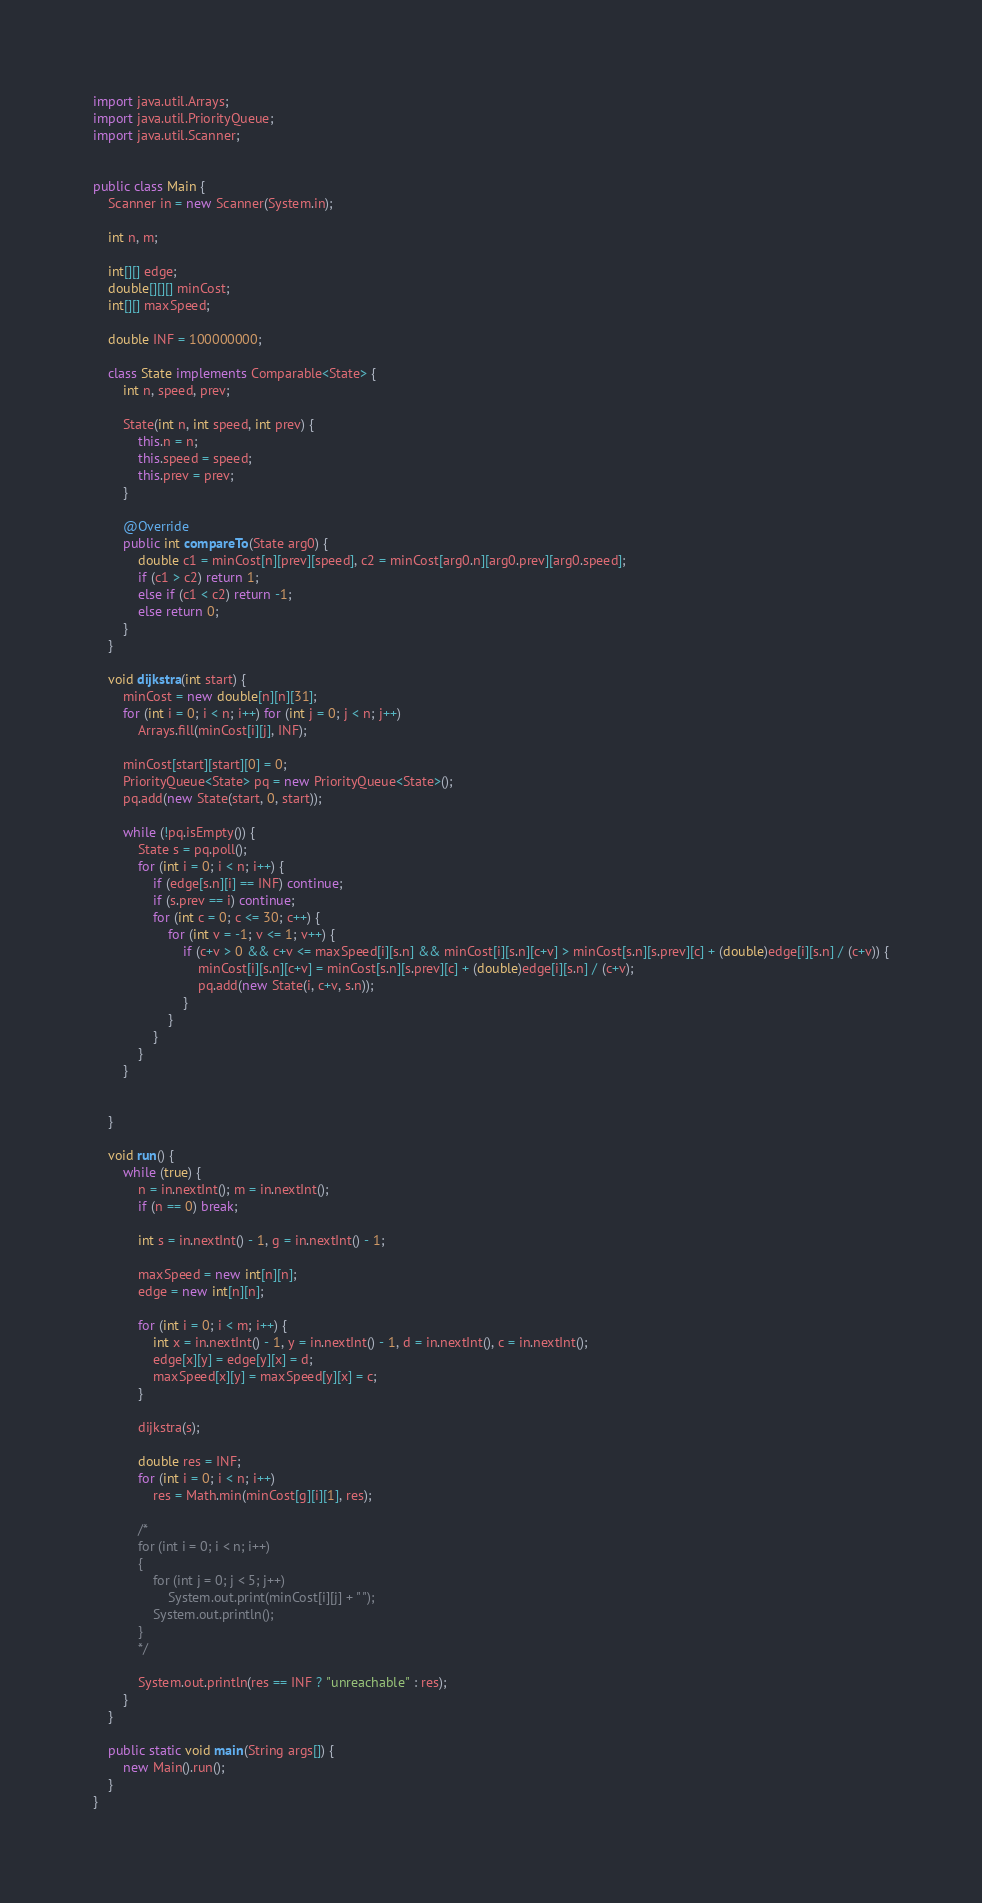Convert code to text. <code><loc_0><loc_0><loc_500><loc_500><_Java_>import java.util.Arrays;
import java.util.PriorityQueue;
import java.util.Scanner;


public class Main {
	Scanner in = new Scanner(System.in);
	
	int n, m;
	
	int[][] edge;
	double[][][] minCost;
	int[][] maxSpeed;	
	
	double INF = 100000000;
	
	class State implements Comparable<State> {
		int n, speed, prev;

		State(int n, int speed, int prev) {
			this.n = n;
			this.speed = speed;
			this.prev = prev;
		}
		
		@Override
		public int compareTo(State arg0) {
			double c1 = minCost[n][prev][speed], c2 = minCost[arg0.n][arg0.prev][arg0.speed];
			if (c1 > c2) return 1;
			else if (c1 < c2) return -1;
			else return 0;
		}
	}
	
	void dijkstra(int start) {
		minCost = new double[n][n][31];
		for (int i = 0; i < n; i++) for (int j = 0; j < n; j++)
			Arrays.fill(minCost[i][j], INF);
		
		minCost[start][start][0] = 0;
		PriorityQueue<State> pq = new PriorityQueue<State>();
		pq.add(new State(start, 0, start));
		
		while (!pq.isEmpty()) {
			State s = pq.poll();
			for (int i = 0; i < n; i++) {
				if (edge[s.n][i] == INF) continue;
				if (s.prev == i) continue;
				for (int c = 0; c <= 30; c++) {
					for (int v = -1; v <= 1; v++) {
						if (c+v > 0 && c+v <= maxSpeed[i][s.n] && minCost[i][s.n][c+v] > minCost[s.n][s.prev][c] + (double)edge[i][s.n] / (c+v)) {
							minCost[i][s.n][c+v] = minCost[s.n][s.prev][c] + (double)edge[i][s.n] / (c+v);
							pq.add(new State(i, c+v, s.n));
						}
					}
				}
			}
		}
		
		
	}
	
	void run() {
		while (true) {
			n = in.nextInt(); m = in.nextInt();
			if (n == 0) break;
			
			int s = in.nextInt() - 1, g = in.nextInt() - 1;

			maxSpeed = new int[n][n];
			edge = new int[n][n];
			
			for (int i = 0; i < m; i++) {
				int x = in.nextInt() - 1, y = in.nextInt() - 1, d = in.nextInt(), c = in.nextInt();
				edge[x][y] = edge[y][x] = d;
				maxSpeed[x][y] = maxSpeed[y][x] = c;
			}
			
			dijkstra(s);
			
			double res = INF;
			for (int i = 0; i < n; i++)
				res = Math.min(minCost[g][i][1], res);
			
			/*
			for (int i = 0; i < n; i++)
			{
				for (int j = 0; j < 5; j++)
					System.out.print(minCost[i][j] + " ");
				System.out.println();
			}
			*/
			
			System.out.println(res == INF ? "unreachable" : res);
		}
	}
	
	public static void main(String args[]) {
		new Main().run();
	}
}</code> 